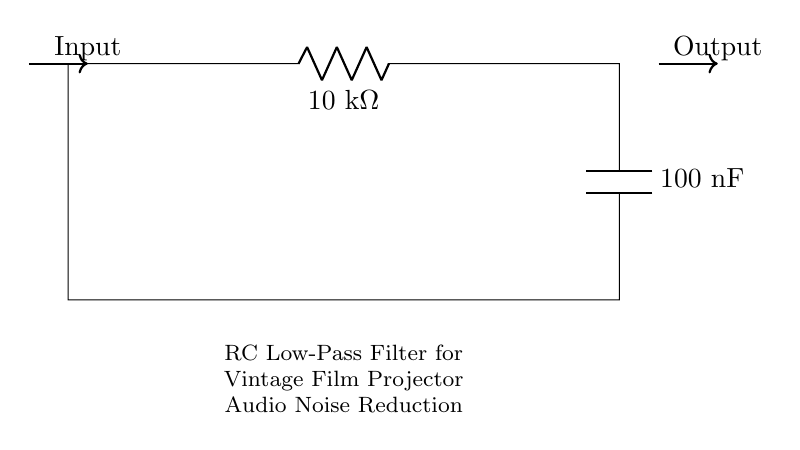What type of circuit is this? This circuit is an RC low-pass filter, which is indicated by the use of a resistor and capacitor. The configuration allows it to pass low-frequency signals while attenuating high-frequency noise.
Answer: RC low-pass filter What is the resistance value? The resistance value is given next to the resistor symbol in the diagram, which shows that the resistor has a value of ten kilohms.
Answer: Ten kilohms What is the capacitance value? The capacitance value is located next to the capacitor symbol in the diagram, indicating that the capacitor has a value of one hundred nanofarads.
Answer: One hundred nanofarads What is the purpose of the RC filter in this circuit? The purpose of the RC filter is to reduce noise in the audio signals of vintage film projectors, allowing clearer sound reproduction while filtering out unwanted high-frequency components.
Answer: Noise reduction How does the RC filter affect high-frequency signals? The RC filter, by design, attenuates high-frequency signals due to its low-pass filter characteristic, allowing mainly low-frequency signals to pass through while reducing the amplitude of higher frequencies.
Answer: Attenuates What can be inferred about the input and output connections? The input connection is where the noisy signal enters the circuit, and the output connection is where the filtered (reduced noise) signal exits the circuit, reflecting the primary function of the filter to process audio signals.
Answer: Input and output for signal processing 